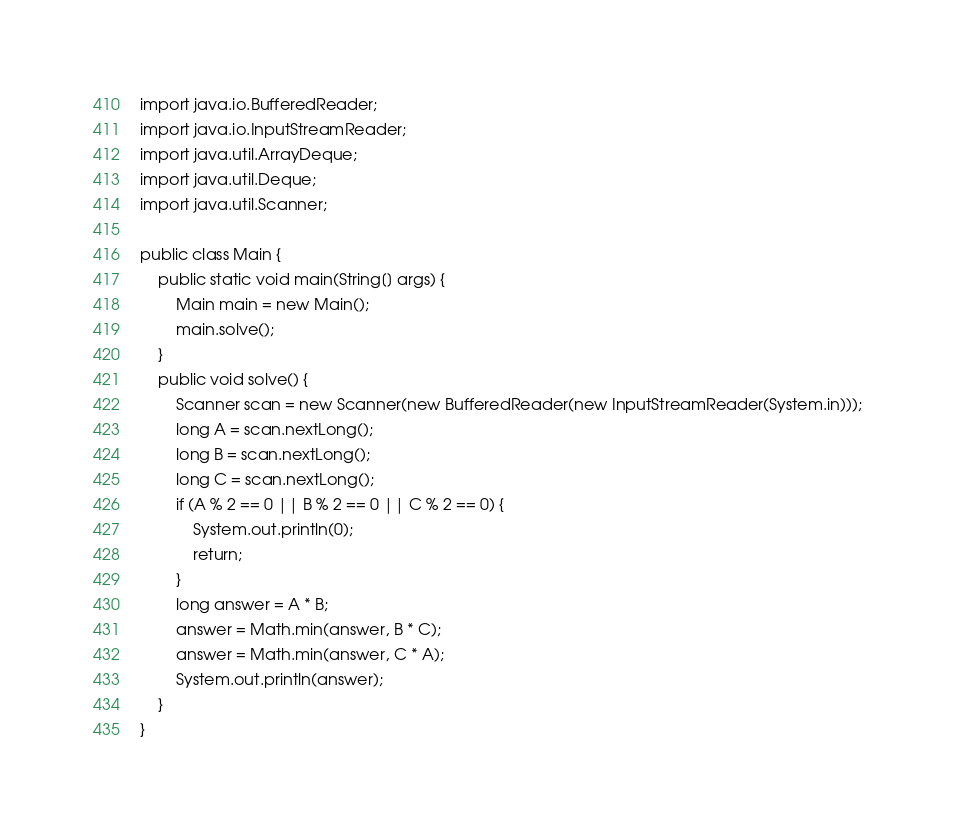<code> <loc_0><loc_0><loc_500><loc_500><_Java_>import java.io.BufferedReader;
import java.io.InputStreamReader;
import java.util.ArrayDeque;
import java.util.Deque;
import java.util.Scanner;

public class Main {
    public static void main(String[] args) {
        Main main = new Main();
        main.solve();
    }
    public void solve() {
        Scanner scan = new Scanner(new BufferedReader(new InputStreamReader(System.in)));
        long A = scan.nextLong();
        long B = scan.nextLong();
        long C = scan.nextLong();
        if (A % 2 == 0 || B % 2 == 0 || C % 2 == 0) {
            System.out.println(0);
            return;
        }
        long answer = A * B;
        answer = Math.min(answer, B * C);
        answer = Math.min(answer, C * A);
        System.out.println(answer);
    }
}
</code> 